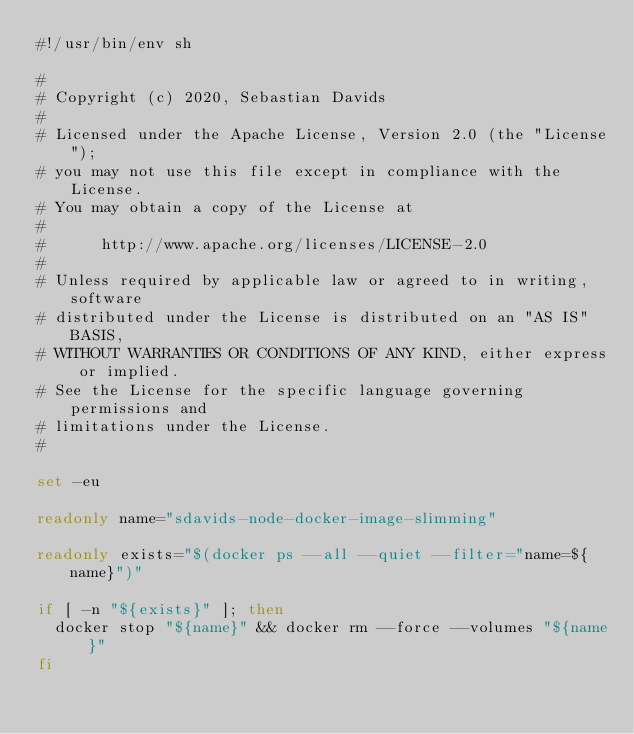Convert code to text. <code><loc_0><loc_0><loc_500><loc_500><_Bash_>#!/usr/bin/env sh

#
# Copyright (c) 2020, Sebastian Davids
#
# Licensed under the Apache License, Version 2.0 (the "License");
# you may not use this file except in compliance with the License.
# You may obtain a copy of the License at
#
#      http://www.apache.org/licenses/LICENSE-2.0
#
# Unless required by applicable law or agreed to in writing, software
# distributed under the License is distributed on an "AS IS" BASIS,
# WITHOUT WARRANTIES OR CONDITIONS OF ANY KIND, either express or implied.
# See the License for the specific language governing permissions and
# limitations under the License.
#

set -eu

readonly name="sdavids-node-docker-image-slimming"

readonly exists="$(docker ps --all --quiet --filter="name=${name}")"

if [ -n "${exists}" ]; then
  docker stop "${name}" && docker rm --force --volumes "${name}"
fi
</code> 